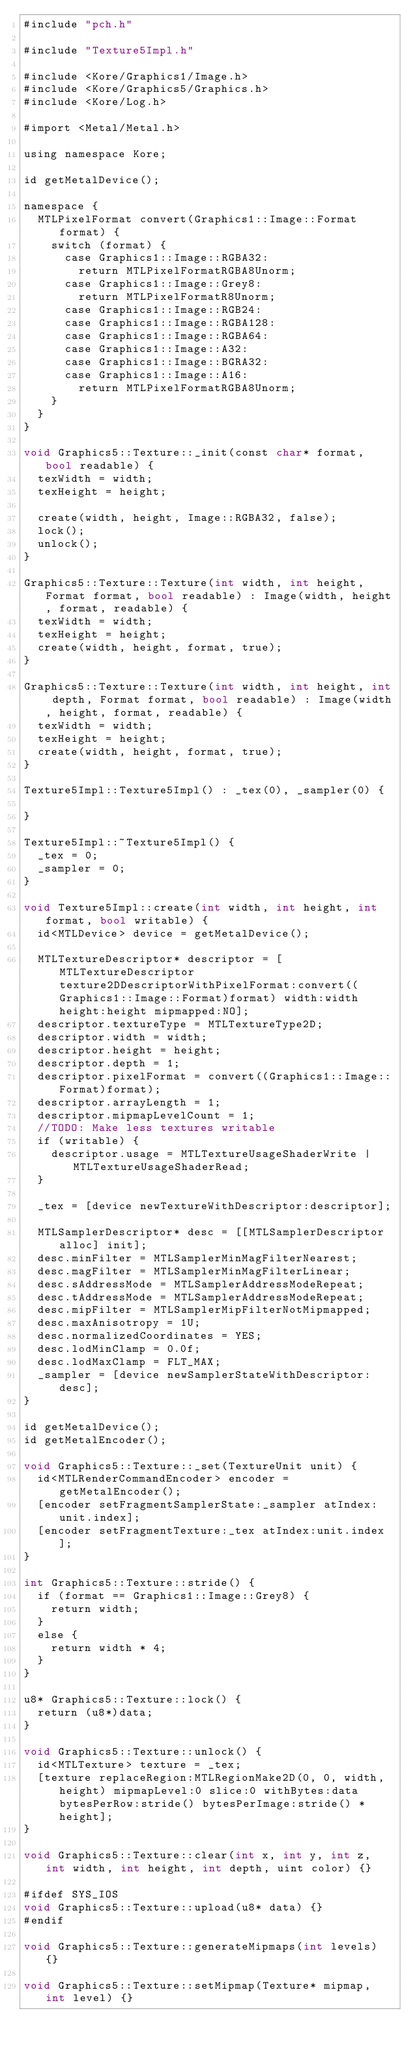<code> <loc_0><loc_0><loc_500><loc_500><_ObjectiveC_>#include "pch.h"

#include "Texture5Impl.h"

#include <Kore/Graphics1/Image.h>
#include <Kore/Graphics5/Graphics.h>
#include <Kore/Log.h>

#import <Metal/Metal.h>

using namespace Kore;

id getMetalDevice();

namespace {
	MTLPixelFormat convert(Graphics1::Image::Format format) {
		switch (format) {
			case Graphics1::Image::RGBA32:
				return MTLPixelFormatRGBA8Unorm;
			case Graphics1::Image::Grey8:
				return MTLPixelFormatR8Unorm;
			case Graphics1::Image::RGB24:
			case Graphics1::Image::RGBA128:
			case Graphics1::Image::RGBA64:
			case Graphics1::Image::A32:
			case Graphics1::Image::BGRA32:
			case Graphics1::Image::A16:
				return MTLPixelFormatRGBA8Unorm;
		}
	}
}

void Graphics5::Texture::_init(const char* format, bool readable) {
	texWidth = width;
	texHeight = height;

	create(width, height, Image::RGBA32, false);
	lock();
	unlock();
}

Graphics5::Texture::Texture(int width, int height, Format format, bool readable) : Image(width, height, format, readable) {
	texWidth = width;
	texHeight = height;
	create(width, height, format, true);
}

Graphics5::Texture::Texture(int width, int height, int depth, Format format, bool readable) : Image(width, height, format, readable) {
	texWidth = width;
	texHeight = height;
	create(width, height, format, true);
}

Texture5Impl::Texture5Impl() : _tex(0), _sampler(0) {

}

Texture5Impl::~Texture5Impl() {
	_tex = 0;
	_sampler = 0;
}

void Texture5Impl::create(int width, int height, int format, bool writable) {
	id<MTLDevice> device = getMetalDevice();

	MTLTextureDescriptor* descriptor = [MTLTextureDescriptor texture2DDescriptorWithPixelFormat:convert((Graphics1::Image::Format)format) width:width height:height mipmapped:NO];
	descriptor.textureType = MTLTextureType2D;
	descriptor.width = width;
	descriptor.height = height;
	descriptor.depth = 1;
	descriptor.pixelFormat = convert((Graphics1::Image::Format)format);
	descriptor.arrayLength = 1;
	descriptor.mipmapLevelCount = 1;
	//TODO: Make less textures writable
	if (writable) {
		descriptor.usage = MTLTextureUsageShaderWrite | MTLTextureUsageShaderRead;
	}
	
	_tex = [device newTextureWithDescriptor:descriptor];
	
	MTLSamplerDescriptor* desc = [[MTLSamplerDescriptor alloc] init];
	desc.minFilter = MTLSamplerMinMagFilterNearest;
	desc.magFilter = MTLSamplerMinMagFilterLinear;
	desc.sAddressMode = MTLSamplerAddressModeRepeat;
	desc.tAddressMode = MTLSamplerAddressModeRepeat;
	desc.mipFilter = MTLSamplerMipFilterNotMipmapped;
	desc.maxAnisotropy = 1U;
	desc.normalizedCoordinates = YES;
	desc.lodMinClamp = 0.0f;
	desc.lodMaxClamp = FLT_MAX;
	_sampler = [device newSamplerStateWithDescriptor:desc];
}

id getMetalDevice();
id getMetalEncoder();

void Graphics5::Texture::_set(TextureUnit unit) {
	id<MTLRenderCommandEncoder> encoder = getMetalEncoder();
	[encoder setFragmentSamplerState:_sampler atIndex:unit.index];
	[encoder setFragmentTexture:_tex atIndex:unit.index];
}

int Graphics5::Texture::stride() {
	if (format == Graphics1::Image::Grey8) {
		return width;
	}
	else {
		return width * 4;
	}
}

u8* Graphics5::Texture::lock() {
	return (u8*)data;
}

void Graphics5::Texture::unlock() {
	id<MTLTexture> texture = _tex;
	[texture replaceRegion:MTLRegionMake2D(0, 0, width, height) mipmapLevel:0 slice:0 withBytes:data bytesPerRow:stride() bytesPerImage:stride() * height];
}

void Graphics5::Texture::clear(int x, int y, int z, int width, int height, int depth, uint color) {}

#ifdef SYS_IOS
void Graphics5::Texture::upload(u8* data) {}
#endif

void Graphics5::Texture::generateMipmaps(int levels) {}

void Graphics5::Texture::setMipmap(Texture* mipmap, int level) {}
</code> 